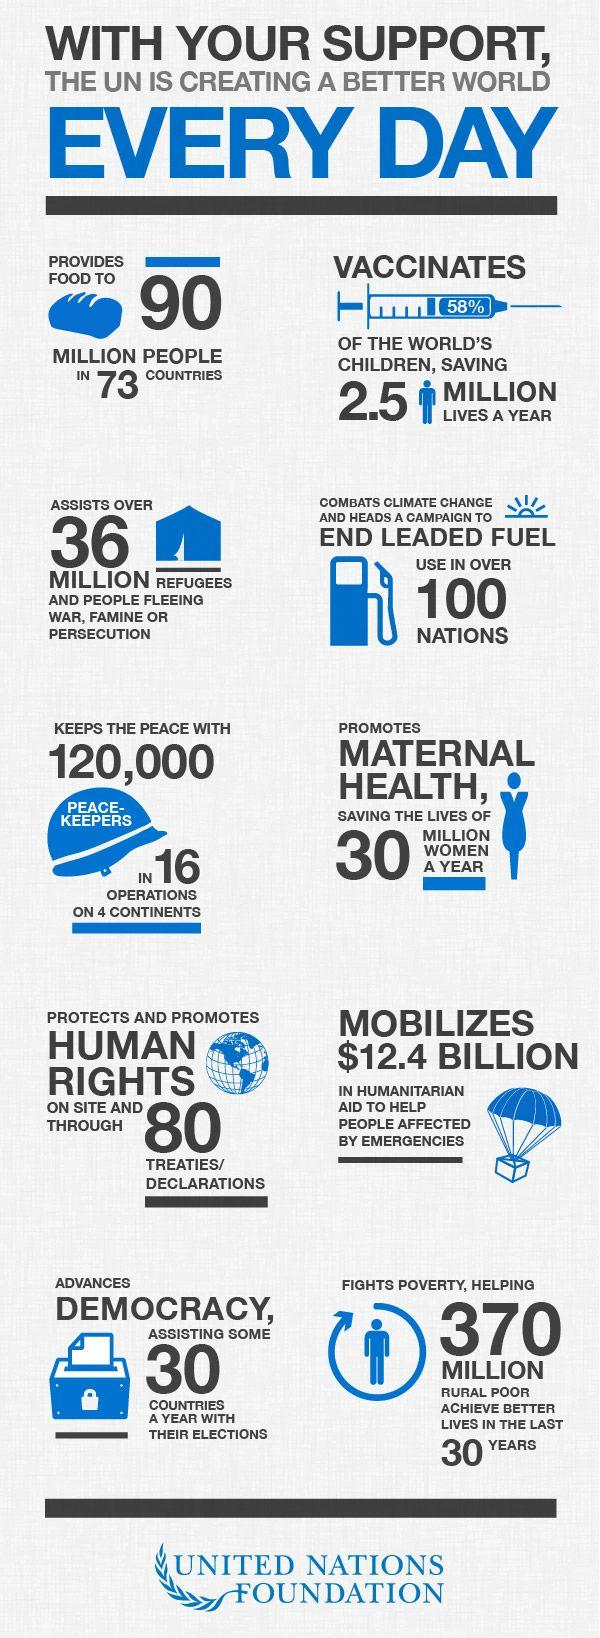Mention a couple of crucial points in this snapshot. The hat features the written message 'peace-keepers,' which denotes the wearer's dedication to maintaining order and stability. The label on the syringe reads "58%. 